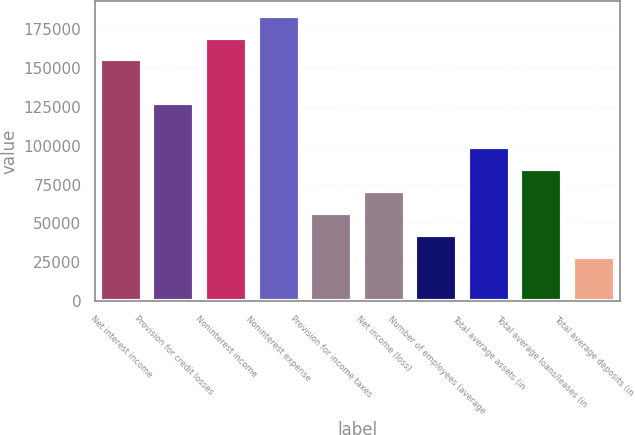Convert chart to OTSL. <chart><loc_0><loc_0><loc_500><loc_500><bar_chart><fcel>Net interest income<fcel>Provision for credit losses<fcel>Noninterest income<fcel>Noninterest expense<fcel>Provision for income taxes<fcel>Net income (loss)<fcel>Number of employees (average<fcel>Total average assets (in<fcel>Total average loans/leases (in<fcel>Total average deposits (in<nl><fcel>155638<fcel>127340<fcel>169787<fcel>183936<fcel>56595.9<fcel>70744.8<fcel>42447.1<fcel>99042.5<fcel>84893.6<fcel>28298.2<nl></chart> 